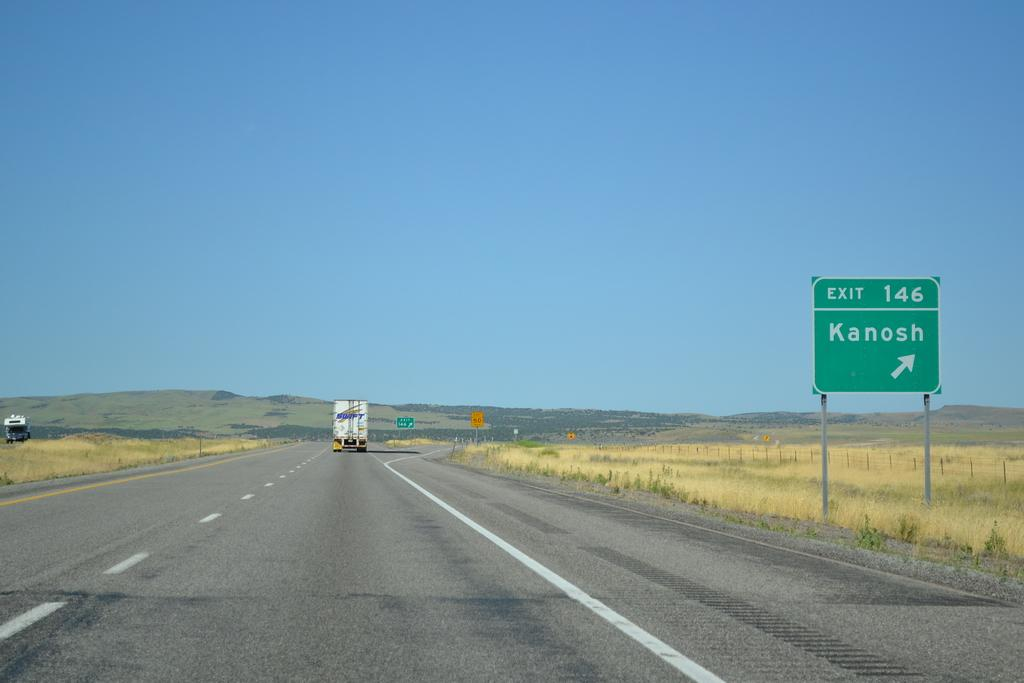<image>
Share a concise interpretation of the image provided. A green exit 146 signs to Kanosh stands along a highway 